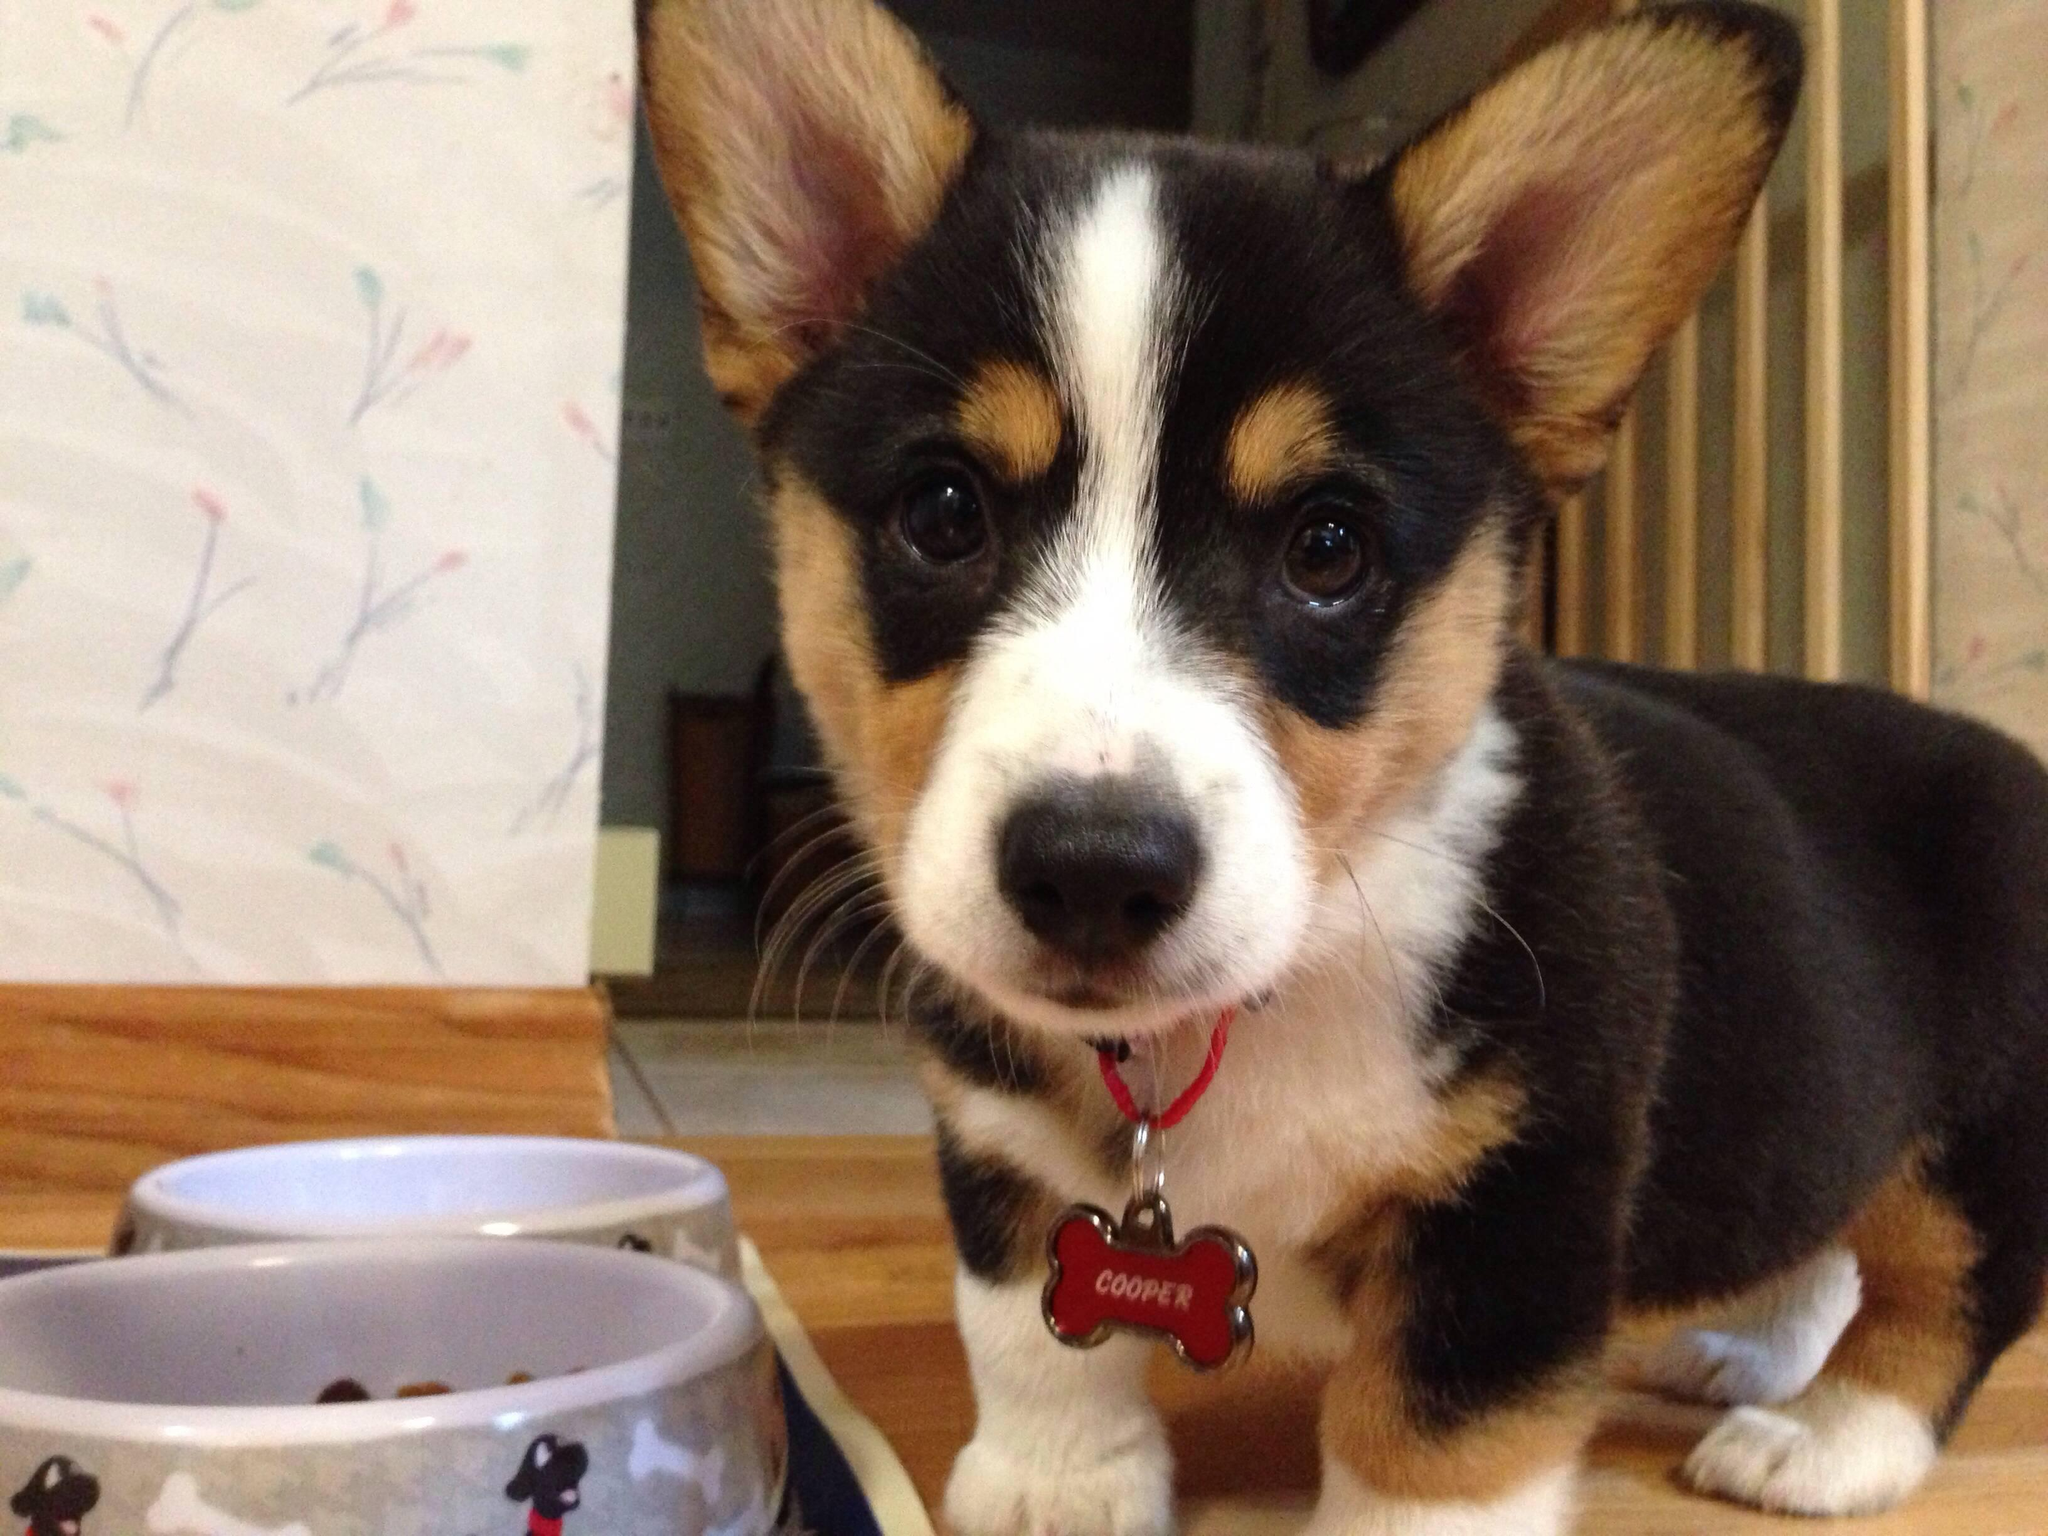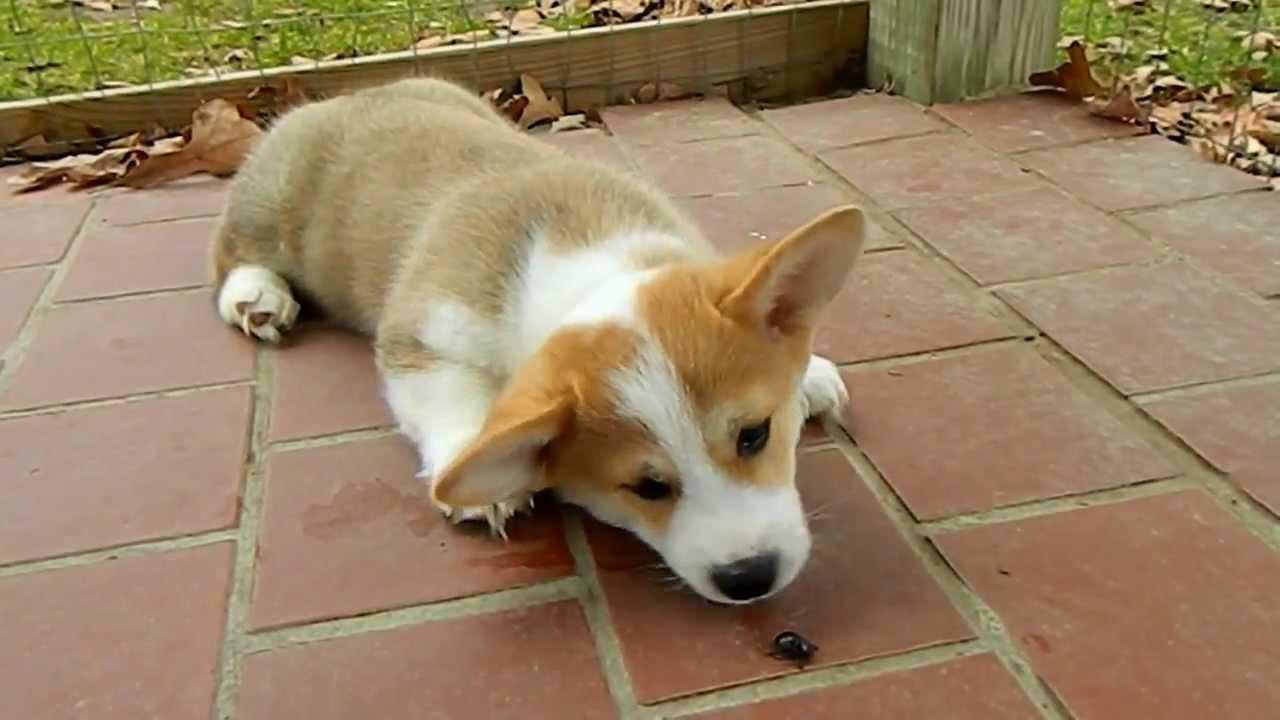The first image is the image on the left, the second image is the image on the right. For the images displayed, is the sentence "At least one puppy is outside." factually correct? Answer yes or no. Yes. The first image is the image on the left, the second image is the image on the right. For the images displayed, is the sentence "At least one pup is outside." factually correct? Answer yes or no. Yes. 